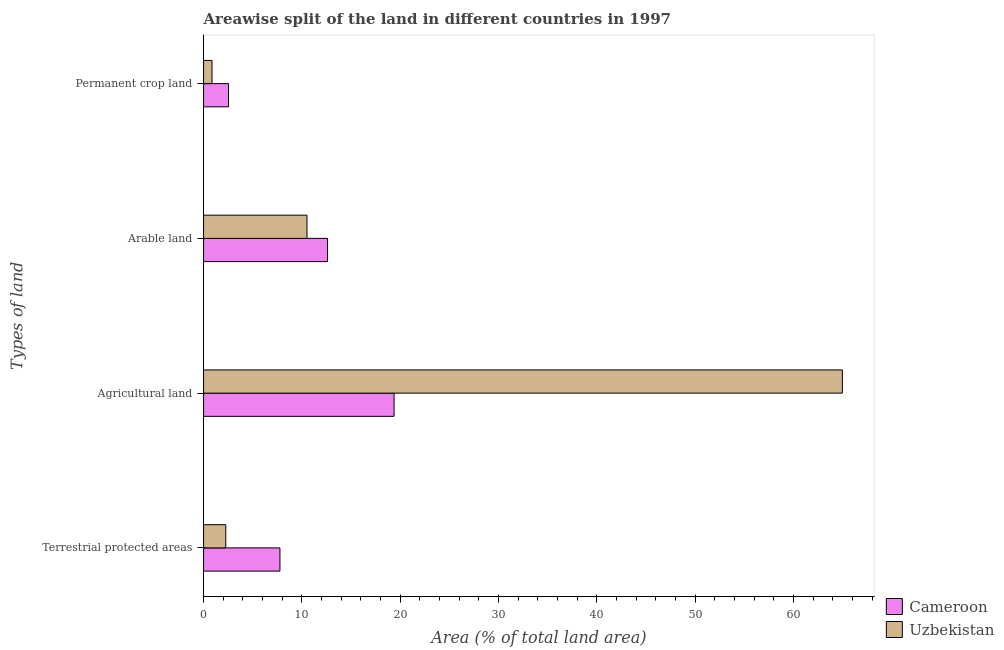How many different coloured bars are there?
Your response must be concise. 2. What is the label of the 2nd group of bars from the top?
Your answer should be compact. Arable land. What is the percentage of area under agricultural land in Cameroon?
Your answer should be very brief. 19.38. Across all countries, what is the maximum percentage of area under arable land?
Ensure brevity in your answer.  12.61. Across all countries, what is the minimum percentage of land under terrestrial protection?
Offer a terse response. 2.26. In which country was the percentage of land under terrestrial protection maximum?
Offer a very short reply. Cameroon. In which country was the percentage of area under agricultural land minimum?
Give a very brief answer. Cameroon. What is the total percentage of area under arable land in the graph?
Provide a succinct answer. 23.13. What is the difference between the percentage of area under agricultural land in Uzbekistan and that in Cameroon?
Your answer should be compact. 45.6. What is the difference between the percentage of land under terrestrial protection in Uzbekistan and the percentage of area under arable land in Cameroon?
Keep it short and to the point. -10.35. What is the average percentage of land under terrestrial protection per country?
Give a very brief answer. 5.01. What is the difference between the percentage of land under terrestrial protection and percentage of area under permanent crop land in Cameroon?
Ensure brevity in your answer.  5.23. In how many countries, is the percentage of area under agricultural land greater than 20 %?
Offer a terse response. 1. What is the ratio of the percentage of land under terrestrial protection in Cameroon to that in Uzbekistan?
Your answer should be very brief. 3.44. Is the percentage of area under arable land in Cameroon less than that in Uzbekistan?
Offer a very short reply. No. Is the difference between the percentage of area under permanent crop land in Uzbekistan and Cameroon greater than the difference between the percentage of area under arable land in Uzbekistan and Cameroon?
Keep it short and to the point. Yes. What is the difference between the highest and the second highest percentage of area under arable land?
Your answer should be compact. 2.09. What is the difference between the highest and the lowest percentage of area under arable land?
Your answer should be compact. 2.09. Is it the case that in every country, the sum of the percentage of area under agricultural land and percentage of area under arable land is greater than the sum of percentage of land under terrestrial protection and percentage of area under permanent crop land?
Your response must be concise. Yes. What does the 2nd bar from the top in Permanent crop land represents?
Give a very brief answer. Cameroon. What does the 1st bar from the bottom in Terrestrial protected areas represents?
Offer a very short reply. Cameroon. Is it the case that in every country, the sum of the percentage of land under terrestrial protection and percentage of area under agricultural land is greater than the percentage of area under arable land?
Your answer should be very brief. Yes. How many bars are there?
Your answer should be very brief. 8. What is the difference between two consecutive major ticks on the X-axis?
Your answer should be compact. 10. Are the values on the major ticks of X-axis written in scientific E-notation?
Offer a terse response. No. Where does the legend appear in the graph?
Keep it short and to the point. Bottom right. How are the legend labels stacked?
Your answer should be very brief. Vertical. What is the title of the graph?
Provide a short and direct response. Areawise split of the land in different countries in 1997. Does "Kuwait" appear as one of the legend labels in the graph?
Offer a very short reply. No. What is the label or title of the X-axis?
Make the answer very short. Area (% of total land area). What is the label or title of the Y-axis?
Give a very brief answer. Types of land. What is the Area (% of total land area) of Cameroon in Terrestrial protected areas?
Provide a succinct answer. 7.77. What is the Area (% of total land area) of Uzbekistan in Terrestrial protected areas?
Make the answer very short. 2.26. What is the Area (% of total land area) in Cameroon in Agricultural land?
Give a very brief answer. 19.38. What is the Area (% of total land area) of Uzbekistan in Agricultural land?
Your response must be concise. 64.97. What is the Area (% of total land area) of Cameroon in Arable land?
Provide a short and direct response. 12.61. What is the Area (% of total land area) in Uzbekistan in Arable land?
Offer a terse response. 10.52. What is the Area (% of total land area) in Cameroon in Permanent crop land?
Your answer should be compact. 2.54. What is the Area (% of total land area) of Uzbekistan in Permanent crop land?
Give a very brief answer. 0.86. Across all Types of land, what is the maximum Area (% of total land area) of Cameroon?
Your response must be concise. 19.38. Across all Types of land, what is the maximum Area (% of total land area) in Uzbekistan?
Make the answer very short. 64.97. Across all Types of land, what is the minimum Area (% of total land area) of Cameroon?
Ensure brevity in your answer.  2.54. Across all Types of land, what is the minimum Area (% of total land area) of Uzbekistan?
Offer a very short reply. 0.86. What is the total Area (% of total land area) in Cameroon in the graph?
Your response must be concise. 42.29. What is the total Area (% of total land area) in Uzbekistan in the graph?
Keep it short and to the point. 78.61. What is the difference between the Area (% of total land area) of Cameroon in Terrestrial protected areas and that in Agricultural land?
Offer a terse response. -11.61. What is the difference between the Area (% of total land area) of Uzbekistan in Terrestrial protected areas and that in Agricultural land?
Give a very brief answer. -62.72. What is the difference between the Area (% of total land area) of Cameroon in Terrestrial protected areas and that in Arable land?
Your answer should be very brief. -4.84. What is the difference between the Area (% of total land area) in Uzbekistan in Terrestrial protected areas and that in Arable land?
Your response must be concise. -8.26. What is the difference between the Area (% of total land area) of Cameroon in Terrestrial protected areas and that in Permanent crop land?
Make the answer very short. 5.23. What is the difference between the Area (% of total land area) of Uzbekistan in Terrestrial protected areas and that in Permanent crop land?
Offer a terse response. 1.4. What is the difference between the Area (% of total land area) of Cameroon in Agricultural land and that in Arable land?
Ensure brevity in your answer.  6.77. What is the difference between the Area (% of total land area) of Uzbekistan in Agricultural land and that in Arable land?
Your answer should be compact. 54.45. What is the difference between the Area (% of total land area) in Cameroon in Agricultural land and that in Permanent crop land?
Offer a very short reply. 16.84. What is the difference between the Area (% of total land area) of Uzbekistan in Agricultural land and that in Permanent crop land?
Ensure brevity in your answer.  64.12. What is the difference between the Area (% of total land area) of Cameroon in Arable land and that in Permanent crop land?
Your answer should be compact. 10.07. What is the difference between the Area (% of total land area) of Uzbekistan in Arable land and that in Permanent crop land?
Keep it short and to the point. 9.66. What is the difference between the Area (% of total land area) in Cameroon in Terrestrial protected areas and the Area (% of total land area) in Uzbekistan in Agricultural land?
Your response must be concise. -57.21. What is the difference between the Area (% of total land area) in Cameroon in Terrestrial protected areas and the Area (% of total land area) in Uzbekistan in Arable land?
Make the answer very short. -2.75. What is the difference between the Area (% of total land area) of Cameroon in Terrestrial protected areas and the Area (% of total land area) of Uzbekistan in Permanent crop land?
Offer a very short reply. 6.91. What is the difference between the Area (% of total land area) in Cameroon in Agricultural land and the Area (% of total land area) in Uzbekistan in Arable land?
Provide a succinct answer. 8.86. What is the difference between the Area (% of total land area) of Cameroon in Agricultural land and the Area (% of total land area) of Uzbekistan in Permanent crop land?
Offer a very short reply. 18.52. What is the difference between the Area (% of total land area) of Cameroon in Arable land and the Area (% of total land area) of Uzbekistan in Permanent crop land?
Keep it short and to the point. 11.75. What is the average Area (% of total land area) of Cameroon per Types of land?
Give a very brief answer. 10.57. What is the average Area (% of total land area) in Uzbekistan per Types of land?
Make the answer very short. 19.65. What is the difference between the Area (% of total land area) in Cameroon and Area (% of total land area) in Uzbekistan in Terrestrial protected areas?
Your answer should be compact. 5.51. What is the difference between the Area (% of total land area) of Cameroon and Area (% of total land area) of Uzbekistan in Agricultural land?
Give a very brief answer. -45.6. What is the difference between the Area (% of total land area) of Cameroon and Area (% of total land area) of Uzbekistan in Arable land?
Offer a terse response. 2.09. What is the difference between the Area (% of total land area) of Cameroon and Area (% of total land area) of Uzbekistan in Permanent crop land?
Offer a very short reply. 1.68. What is the ratio of the Area (% of total land area) of Cameroon in Terrestrial protected areas to that in Agricultural land?
Your answer should be compact. 0.4. What is the ratio of the Area (% of total land area) of Uzbekistan in Terrestrial protected areas to that in Agricultural land?
Give a very brief answer. 0.03. What is the ratio of the Area (% of total land area) of Cameroon in Terrestrial protected areas to that in Arable land?
Give a very brief answer. 0.62. What is the ratio of the Area (% of total land area) of Uzbekistan in Terrestrial protected areas to that in Arable land?
Offer a terse response. 0.21. What is the ratio of the Area (% of total land area) of Cameroon in Terrestrial protected areas to that in Permanent crop land?
Provide a short and direct response. 3.06. What is the ratio of the Area (% of total land area) in Uzbekistan in Terrestrial protected areas to that in Permanent crop land?
Make the answer very short. 2.63. What is the ratio of the Area (% of total land area) of Cameroon in Agricultural land to that in Arable land?
Your answer should be very brief. 1.54. What is the ratio of the Area (% of total land area) in Uzbekistan in Agricultural land to that in Arable land?
Your answer should be compact. 6.18. What is the ratio of the Area (% of total land area) in Cameroon in Agricultural land to that in Permanent crop land?
Make the answer very short. 7.63. What is the ratio of the Area (% of total land area) in Uzbekistan in Agricultural land to that in Permanent crop land?
Your response must be concise. 75.73. What is the ratio of the Area (% of total land area) of Cameroon in Arable land to that in Permanent crop land?
Offer a terse response. 4.97. What is the ratio of the Area (% of total land area) of Uzbekistan in Arable land to that in Permanent crop land?
Provide a short and direct response. 12.26. What is the difference between the highest and the second highest Area (% of total land area) of Cameroon?
Make the answer very short. 6.77. What is the difference between the highest and the second highest Area (% of total land area) in Uzbekistan?
Your response must be concise. 54.45. What is the difference between the highest and the lowest Area (% of total land area) in Cameroon?
Your answer should be very brief. 16.84. What is the difference between the highest and the lowest Area (% of total land area) in Uzbekistan?
Your answer should be very brief. 64.12. 